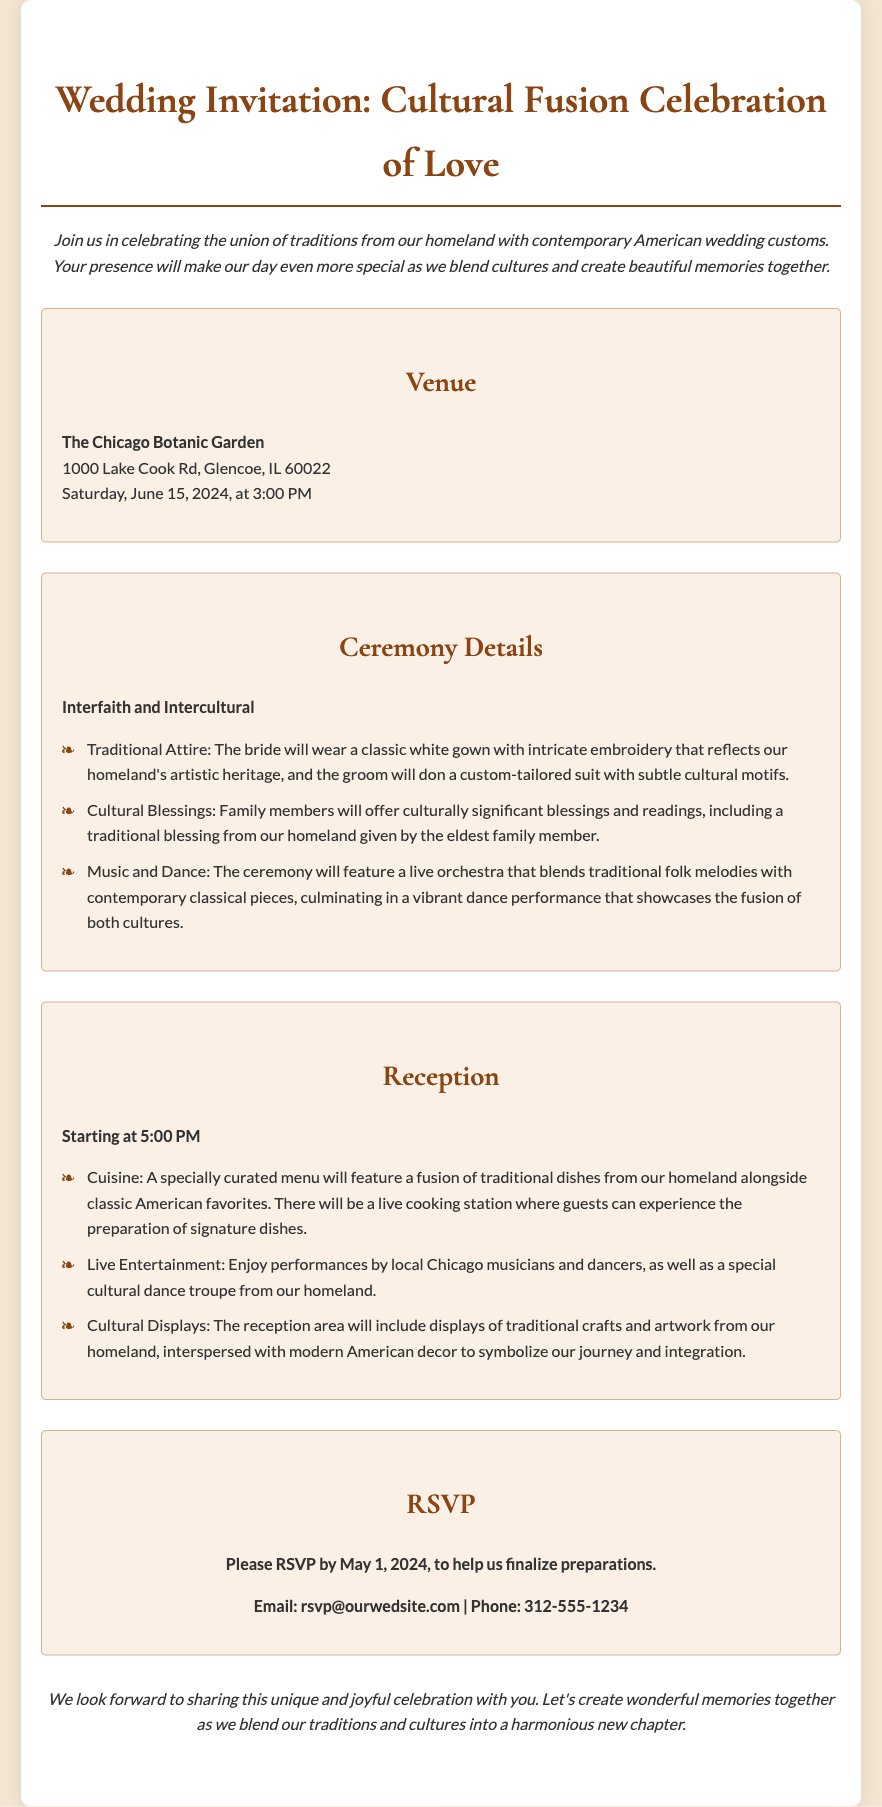What is the date of the wedding? The document specifies the wedding will take place on Saturday, June 15, 2024.
Answer: June 15, 2024 What venue is chosen for the wedding? The venue for the celebration is the Chicago Botanic Garden, as stated in the document.
Answer: The Chicago Botanic Garden What time does the ceremony start? The document indicates that the ceremony will begin at 3:00 PM.
Answer: 3:00 PM What type of attire will the bride wear? The document mentions that the bride will wear a classic white gown with intricate embroidery.
Answer: Classic white gown What will be featured during the reception? The reception will feature live entertainment by local Chicago musicians and dancers.
Answer: Live entertainment How should guests RSVP? Guests are instructed to RSVP via email or phone as listed in the document.
Answer: Email or phone What cultural element will be included in the ceremony? The ceremony includes cultural blessings offered by family members, as described in the document.
Answer: Cultural blessings What kind of cuisine will be served at the reception? The menu will feature a fusion of traditional dishes from the couple's homeland and classic American favorites.
Answer: Fusion of traditional dishes What is the RSVP deadline? The document states that RSVPs are due by May 1, 2024.
Answer: May 1, 2024 